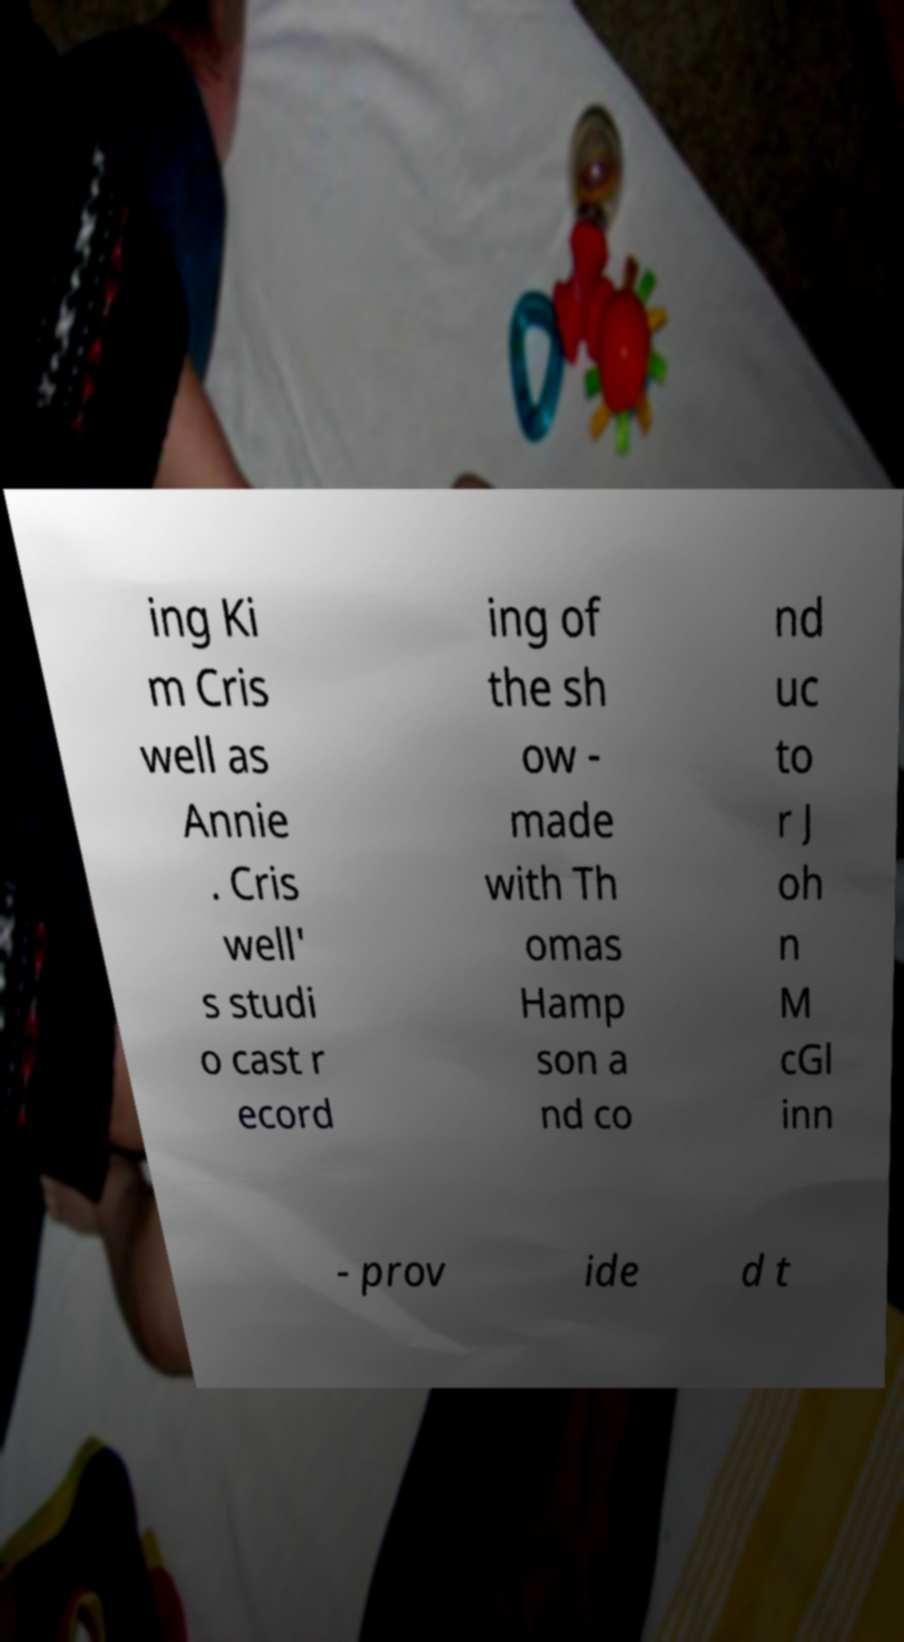I need the written content from this picture converted into text. Can you do that? ing Ki m Cris well as Annie . Cris well' s studi o cast r ecord ing of the sh ow - made with Th omas Hamp son a nd co nd uc to r J oh n M cGl inn - prov ide d t 